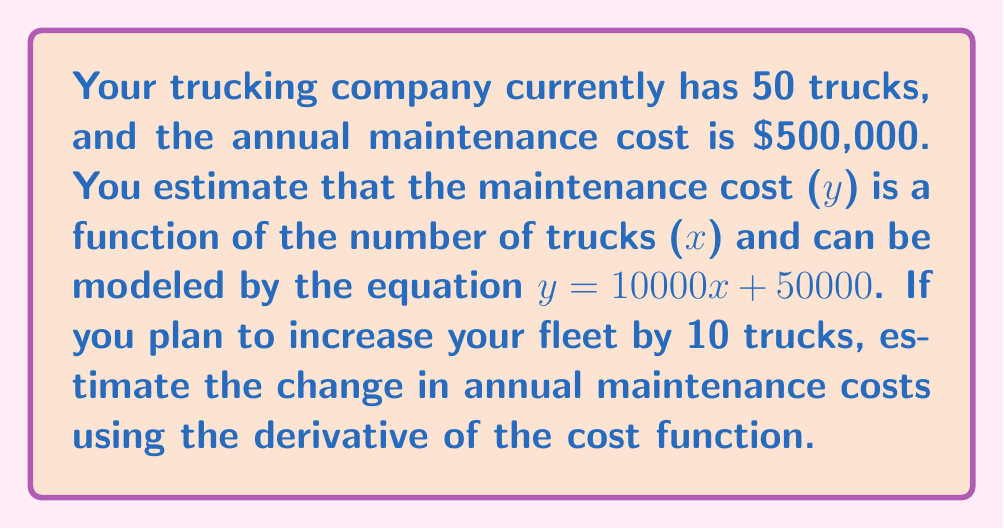Solve this math problem. To solve this problem, we'll follow these steps:

1) First, we need to find the derivative of the cost function.
   The function is $y = 10000x + 50000$
   The derivative is $\frac{dy}{dx} = 10000$

2) The derivative tells us the rate of change of the cost with respect to the number of trucks.

3) We want to estimate the change for an increase of 10 trucks. We can use the derivative to approximate this:

   $\Delta y \approx \frac{dy}{dx} \cdot \Delta x$

   Where $\Delta y$ is the change in cost and $\Delta x$ is the change in number of trucks.

4) Plugging in our values:

   $\Delta y \approx 10000 \cdot 10 = 100000$

5) Therefore, the estimated increase in annual maintenance costs is $100,000.

Note: This is a linear approximation. In reality, the actual change might differ slightly due to non-linear factors not captured in this simple model.
Answer: $100,000 